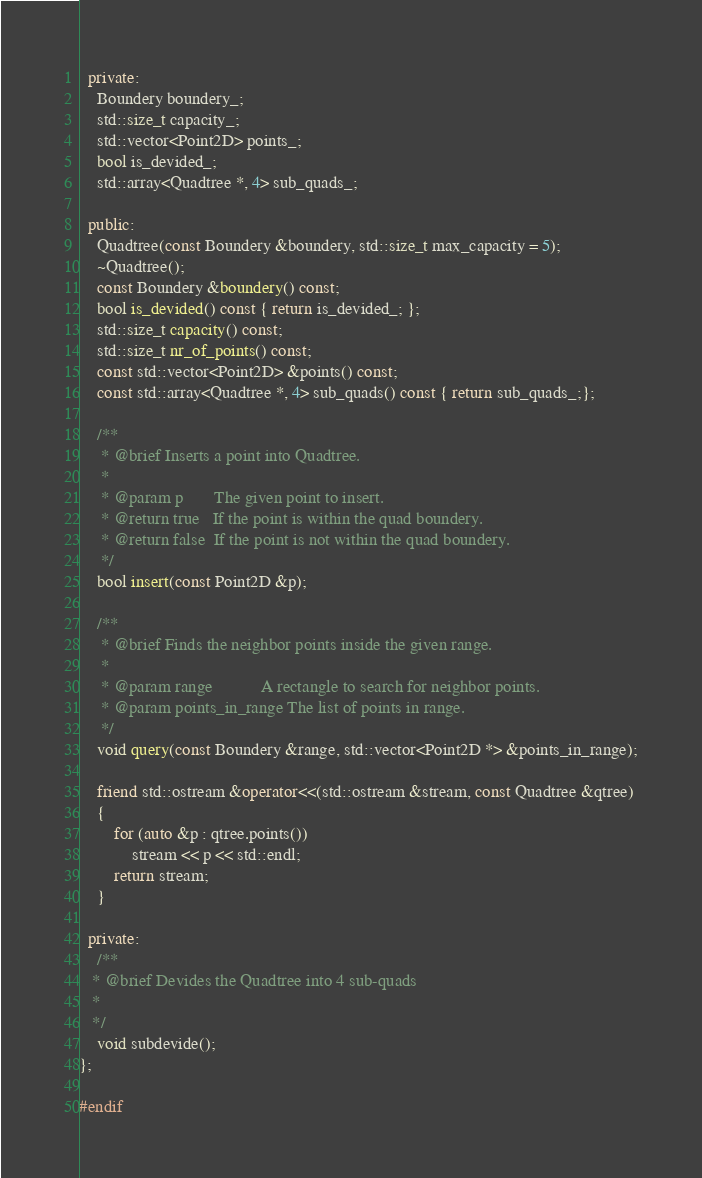<code> <loc_0><loc_0><loc_500><loc_500><_C++_>  private:
    Boundery boundery_;
    std::size_t capacity_;
    std::vector<Point2D> points_;
    bool is_devided_;
    std::array<Quadtree *, 4> sub_quads_;

  public:
    Quadtree(const Boundery &boundery, std::size_t max_capacity = 5);
    ~Quadtree();
    const Boundery &boundery() const;
    bool is_devided() const { return is_devided_; };
    std::size_t capacity() const;
    std::size_t nr_of_points() const;
    const std::vector<Point2D> &points() const;
    const std::array<Quadtree *, 4> sub_quads() const { return sub_quads_;};

    /**
     * @brief Inserts a point into Quadtree.
     * 
     * @param p       The given point to insert.
     * @return true   If the point is within the quad boundery.
     * @return false  If the point is not within the quad boundery.
     */
    bool insert(const Point2D &p);

    /**
     * @brief Finds the neighbor points inside the given range.
     * 
     * @param range           A rectangle to search for neighbor points.
     * @param points_in_range The list of points in range.
     */
    void query(const Boundery &range, std::vector<Point2D *> &points_in_range);

    friend std::ostream &operator<<(std::ostream &stream, const Quadtree &qtree)
    {
        for (auto &p : qtree.points())
            stream << p << std::endl;
        return stream;
    }

  private:
    /**
   * @brief Devides the Quadtree into 4 sub-quads
   * 
   */
    void subdevide();
};

#endif</code> 